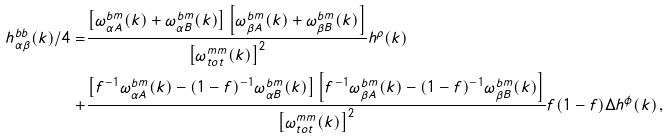<formula> <loc_0><loc_0><loc_500><loc_500>h ^ { b b } _ { \alpha \beta } ( k ) / 4 = & \frac { \left [ \omega ^ { b m } _ { \alpha A } ( k ) + \omega ^ { b m } _ { \alpha B } ( k ) \right ] \left [ \omega ^ { b m } _ { \beta A } ( k ) + \omega ^ { b m } _ { \beta B } ( k ) \right ] } { \left [ \omega ^ { m m } _ { t o t } ( k ) \right ] ^ { 2 } } h ^ { \rho } ( k ) \\ + & \frac { \left [ f ^ { - 1 } \omega ^ { b m } _ { \alpha A } ( k ) - ( 1 - f ) ^ { - 1 } \omega ^ { b m } _ { \alpha B } ( k ) \right ] \left [ f ^ { - 1 } \omega ^ { b m } _ { \beta A } ( k ) - ( 1 - f ) ^ { - 1 } \omega ^ { b m } _ { \beta B } ( k ) \right ] } { \left [ \omega ^ { m m } _ { t o t } ( k ) \right ] ^ { 2 } } f ( 1 - f ) \Delta h ^ { \phi } ( k ) \, ,</formula> 